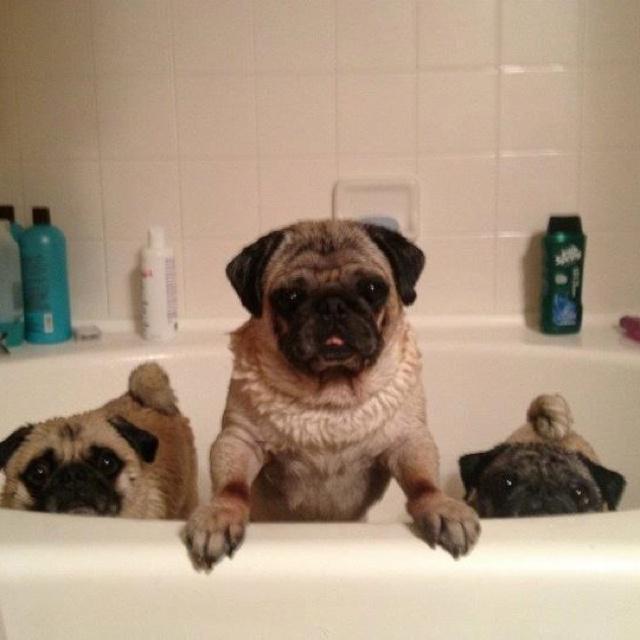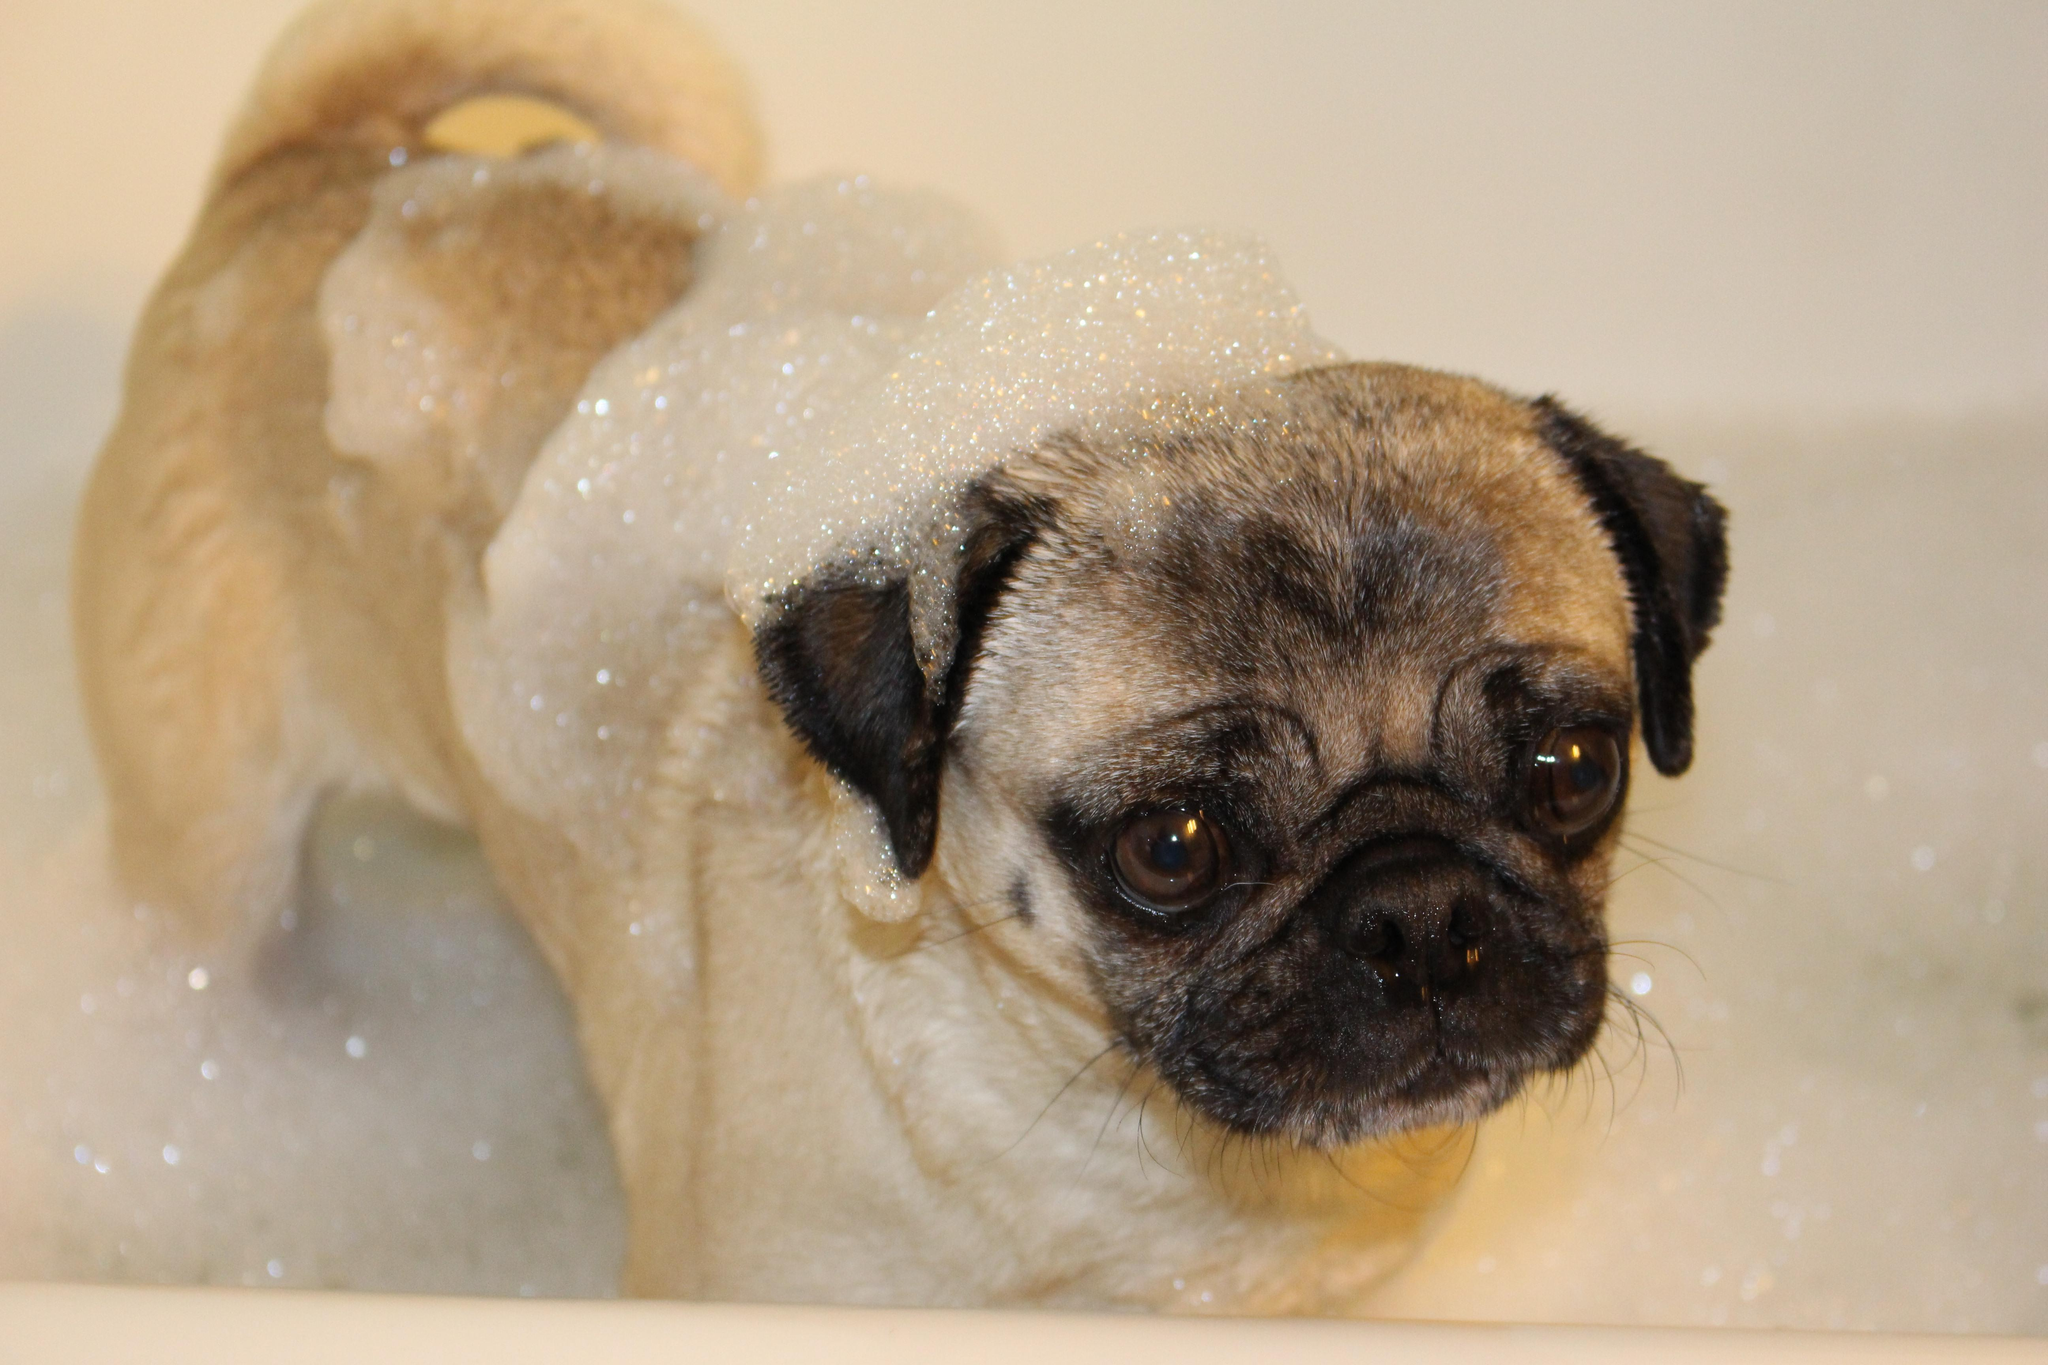The first image is the image on the left, the second image is the image on the right. Assess this claim about the two images: "there are 4 dogs bathing in the image pair". Correct or not? Answer yes or no. Yes. The first image is the image on the left, the second image is the image on the right. Considering the images on both sides, is "One dog has soap on his back." valid? Answer yes or no. Yes. 